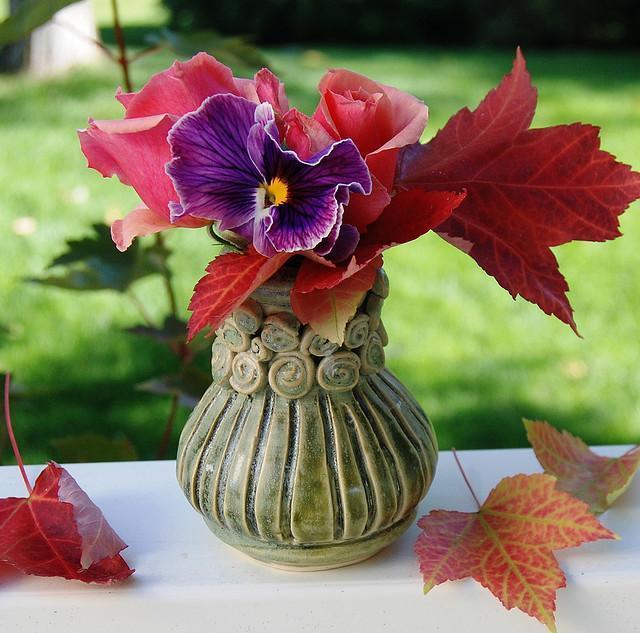How many point are on the front leaf?
Give a very brief answer. 3. 